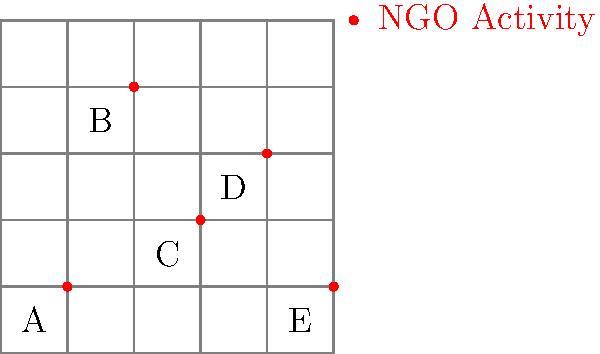Based on the geographical distribution of NGO activities shown in the map, which region appears to have the highest concentration of NGO presence? How might this information be utilized to assess potential areas of concern for government oversight? To analyze the geographical distribution of NGO activities and determine the region with the highest concentration, we need to follow these steps:

1. Observe the map and identify the regions:
   The map is divided into 5 regions labeled A, B, C, D, and E.

2. Count the number of NGO activity points (red dots) in each region:
   Region A: 1 point
   Region B: 1 point
   Region C: 1 point
   Region D: 1 point
   Region E: 1 point

3. Analyze the distribution:
   We can see that each region has exactly one NGO activity point, indicating an even distribution across all regions.

4. Consider the implications:
   Although there is no single region with a higher concentration, the even distribution suggests widespread NGO activity across the entire area.

5. Assess potential areas of concern:
   - The government may need to allocate resources evenly to monitor NGO activities in all regions.
   - The widespread presence may indicate a coordinated effort by NGOs, which could be of interest for government oversight.
   - Each region may require individual assessment to determine the nature and impact of the NGO activities.

6. Utilize the information:
   - Develop region-specific monitoring strategies.
   - Investigate potential connections between NGOs operating in different regions.
   - Allocate manpower and resources proportionally across all regions for effective oversight.

In conclusion, while there is no single region with the highest concentration, the even distribution of NGO activities across all regions presents a unique challenge for government oversight and requires a comprehensive approach to monitoring and controlling the narrative.
Answer: Even distribution; comprehensive monitoring required 